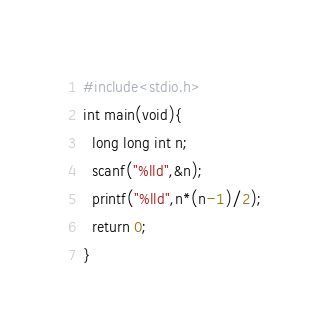Convert code to text. <code><loc_0><loc_0><loc_500><loc_500><_C++_>#include<stdio.h>
int main(void){
  long long int n;
  scanf("%lld",&n);
  printf("%lld",n*(n-1)/2);
  return 0;
}</code> 